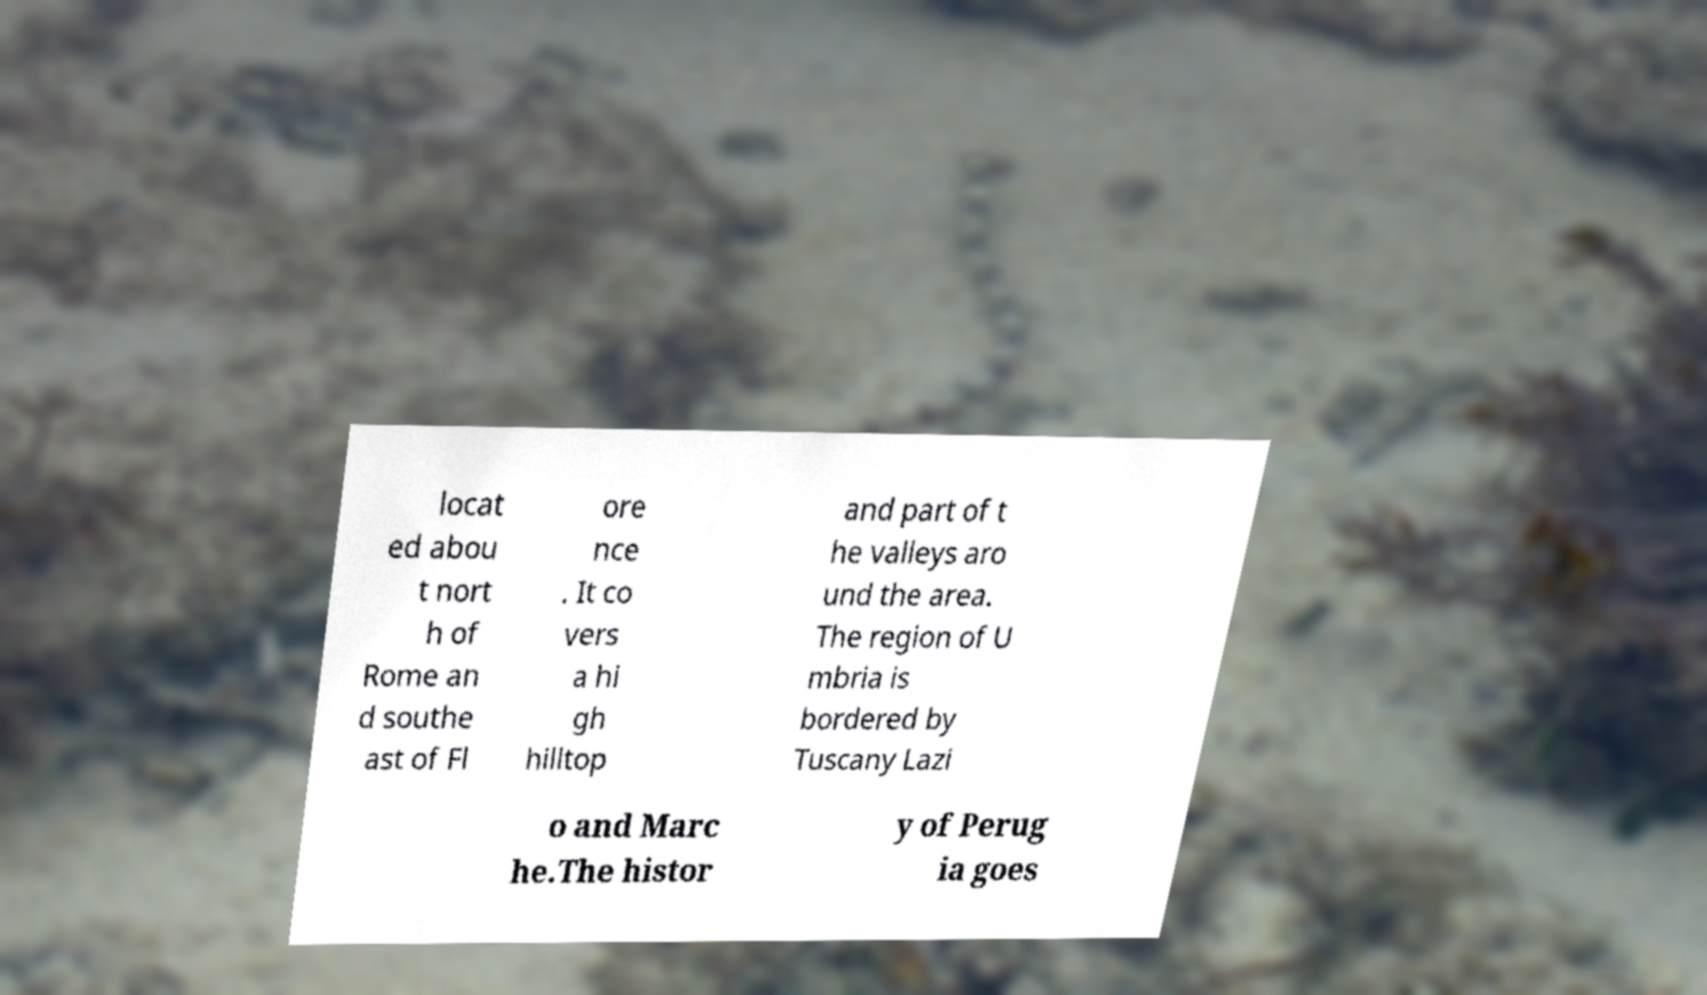Could you extract and type out the text from this image? locat ed abou t nort h of Rome an d southe ast of Fl ore nce . It co vers a hi gh hilltop and part of t he valleys aro und the area. The region of U mbria is bordered by Tuscany Lazi o and Marc he.The histor y of Perug ia goes 